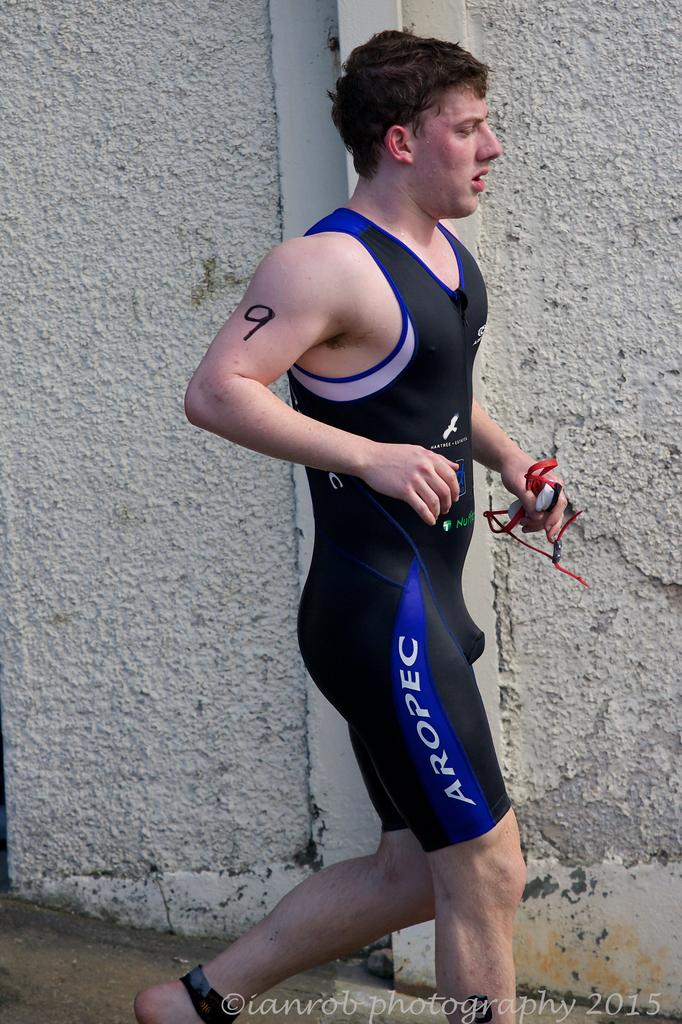<image>
Offer a succinct explanation of the picture presented. A man in an Aropec wetsuit jogs down the street. 